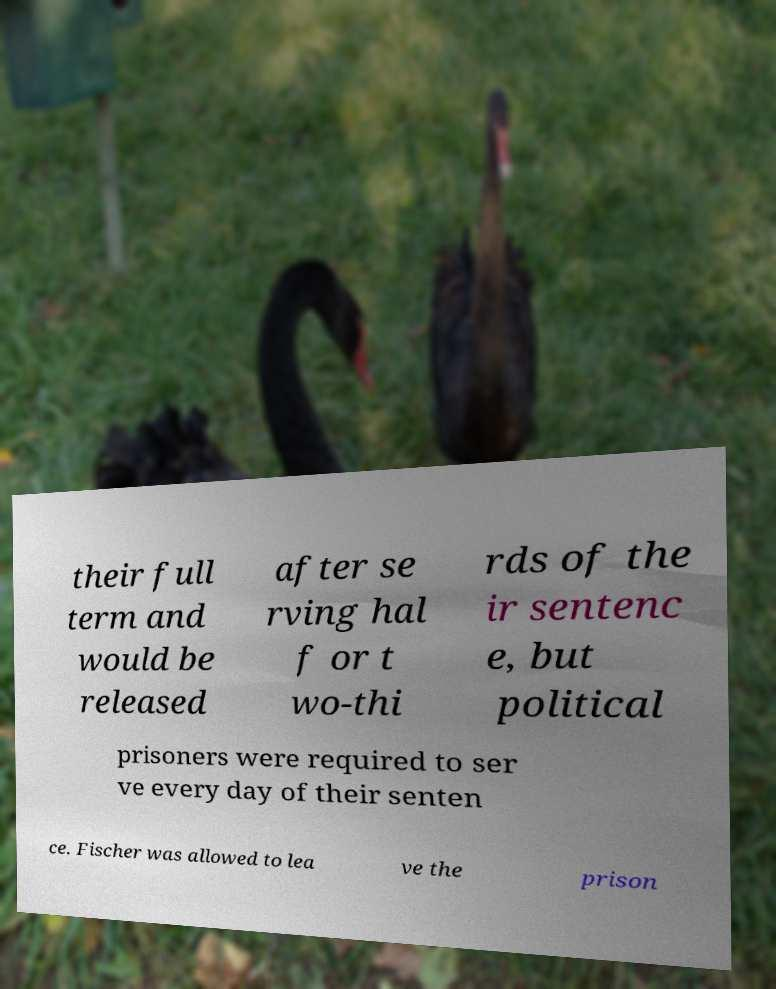What messages or text are displayed in this image? I need them in a readable, typed format. their full term and would be released after se rving hal f or t wo-thi rds of the ir sentenc e, but political prisoners were required to ser ve every day of their senten ce. Fischer was allowed to lea ve the prison 